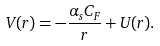<formula> <loc_0><loc_0><loc_500><loc_500>V ( r ) = - \frac { \alpha _ { s } C _ { F } } r + U ( r ) .</formula> 